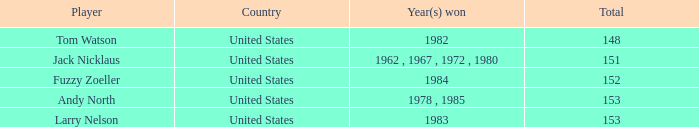What is the Total of the Player with a To par of 4? 1.0. 